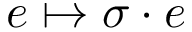<formula> <loc_0><loc_0><loc_500><loc_500>e \mapsto \sigma \cdot e</formula> 